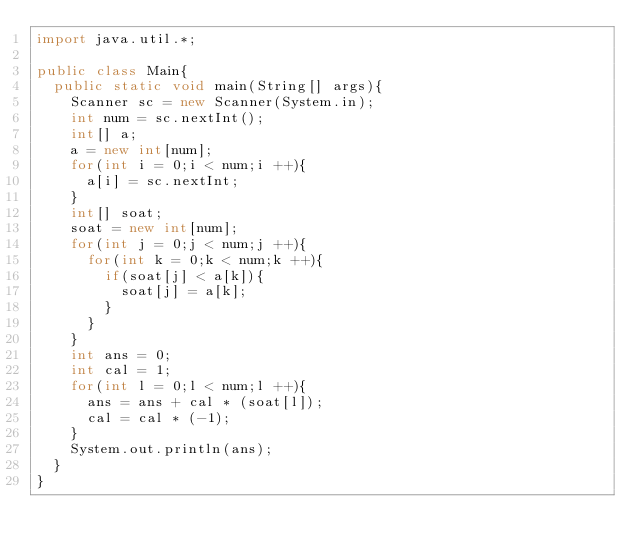Convert code to text. <code><loc_0><loc_0><loc_500><loc_500><_Java_>import java.util.*;

public class Main{
  public static void main(String[] args){
    Scanner sc = new Scanner(System.in);
    int num = sc.nextInt();
    int[] a;
    a = new int[num];
    for(int i = 0;i < num;i ++){
      a[i] = sc.nextInt;
    }
    int[] soat;
    soat = new int[num];
    for(int j = 0;j < num;j ++){
      for(int k = 0;k < num;k ++){
        if(soat[j] < a[k]){
          soat[j] = a[k];
        }
      }
    }
    int ans = 0;
    int cal = 1;
    for(int l = 0;l < num;l ++){
      ans = ans + cal * (soat[l]);
      cal = cal * (-1);
    }
    System.out.println(ans);
  }
}</code> 